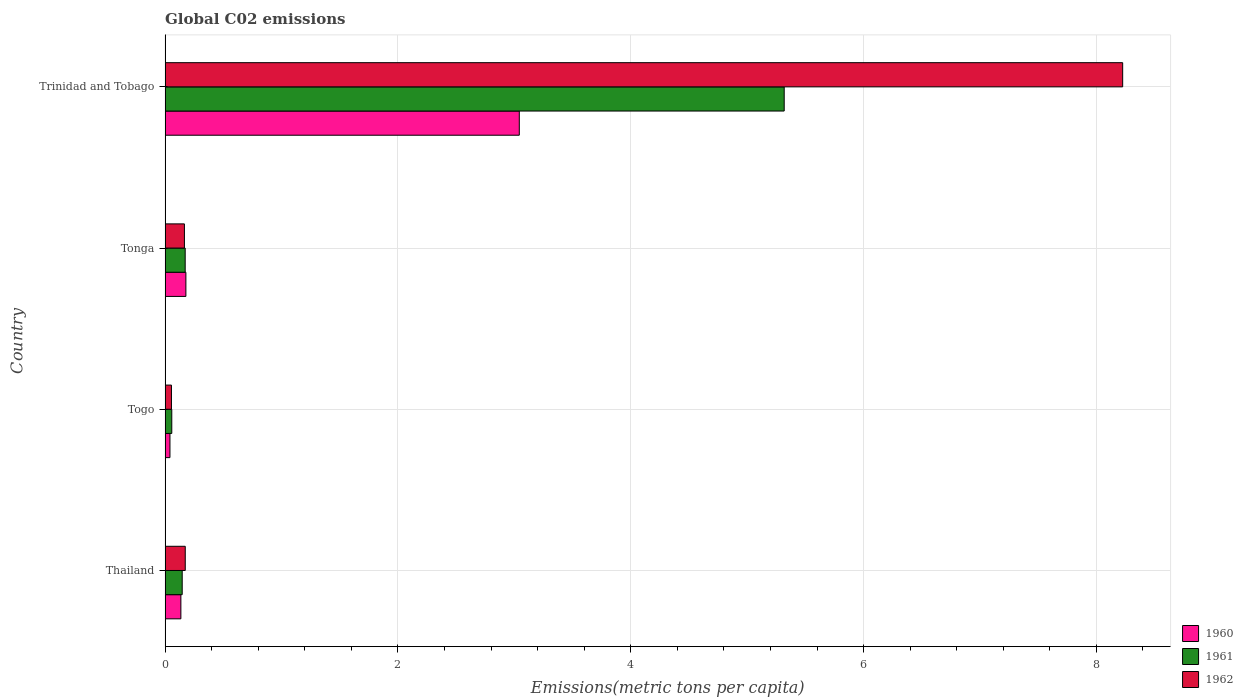How many different coloured bars are there?
Your answer should be compact. 3. How many groups of bars are there?
Keep it short and to the point. 4. How many bars are there on the 1st tick from the top?
Your answer should be compact. 3. What is the label of the 3rd group of bars from the top?
Your response must be concise. Togo. In how many cases, is the number of bars for a given country not equal to the number of legend labels?
Make the answer very short. 0. What is the amount of CO2 emitted in in 1962 in Togo?
Offer a terse response. 0.05. Across all countries, what is the maximum amount of CO2 emitted in in 1961?
Make the answer very short. 5.32. Across all countries, what is the minimum amount of CO2 emitted in in 1962?
Ensure brevity in your answer.  0.05. In which country was the amount of CO2 emitted in in 1962 maximum?
Give a very brief answer. Trinidad and Tobago. In which country was the amount of CO2 emitted in in 1961 minimum?
Offer a terse response. Togo. What is the total amount of CO2 emitted in in 1962 in the graph?
Ensure brevity in your answer.  8.62. What is the difference between the amount of CO2 emitted in in 1961 in Tonga and that in Trinidad and Tobago?
Ensure brevity in your answer.  -5.15. What is the difference between the amount of CO2 emitted in in 1960 in Tonga and the amount of CO2 emitted in in 1961 in Trinidad and Tobago?
Ensure brevity in your answer.  -5.14. What is the average amount of CO2 emitted in in 1961 per country?
Provide a succinct answer. 1.42. What is the difference between the amount of CO2 emitted in in 1962 and amount of CO2 emitted in in 1960 in Tonga?
Give a very brief answer. -0.01. What is the ratio of the amount of CO2 emitted in in 1962 in Thailand to that in Tonga?
Make the answer very short. 1.04. Is the amount of CO2 emitted in in 1961 in Togo less than that in Tonga?
Keep it short and to the point. Yes. Is the difference between the amount of CO2 emitted in in 1962 in Thailand and Tonga greater than the difference between the amount of CO2 emitted in in 1960 in Thailand and Tonga?
Your answer should be compact. Yes. What is the difference between the highest and the second highest amount of CO2 emitted in in 1962?
Make the answer very short. 8.05. What is the difference between the highest and the lowest amount of CO2 emitted in in 1960?
Offer a terse response. 3. In how many countries, is the amount of CO2 emitted in in 1960 greater than the average amount of CO2 emitted in in 1960 taken over all countries?
Provide a short and direct response. 1. Is the sum of the amount of CO2 emitted in in 1962 in Thailand and Tonga greater than the maximum amount of CO2 emitted in in 1960 across all countries?
Your answer should be very brief. No. What does the 3rd bar from the top in Togo represents?
Provide a succinct answer. 1960. What does the 3rd bar from the bottom in Trinidad and Tobago represents?
Your answer should be compact. 1962. Is it the case that in every country, the sum of the amount of CO2 emitted in in 1960 and amount of CO2 emitted in in 1962 is greater than the amount of CO2 emitted in in 1961?
Keep it short and to the point. Yes. How many bars are there?
Your response must be concise. 12. Are all the bars in the graph horizontal?
Provide a short and direct response. Yes. What is the difference between two consecutive major ticks on the X-axis?
Give a very brief answer. 2. Are the values on the major ticks of X-axis written in scientific E-notation?
Offer a terse response. No. Does the graph contain grids?
Keep it short and to the point. Yes. Where does the legend appear in the graph?
Ensure brevity in your answer.  Bottom right. How many legend labels are there?
Ensure brevity in your answer.  3. How are the legend labels stacked?
Provide a short and direct response. Vertical. What is the title of the graph?
Make the answer very short. Global C02 emissions. Does "2005" appear as one of the legend labels in the graph?
Offer a very short reply. No. What is the label or title of the X-axis?
Offer a very short reply. Emissions(metric tons per capita). What is the Emissions(metric tons per capita) of 1960 in Thailand?
Provide a short and direct response. 0.14. What is the Emissions(metric tons per capita) of 1961 in Thailand?
Provide a succinct answer. 0.15. What is the Emissions(metric tons per capita) of 1962 in Thailand?
Give a very brief answer. 0.17. What is the Emissions(metric tons per capita) in 1960 in Togo?
Provide a succinct answer. 0.04. What is the Emissions(metric tons per capita) of 1961 in Togo?
Keep it short and to the point. 0.06. What is the Emissions(metric tons per capita) in 1962 in Togo?
Provide a succinct answer. 0.05. What is the Emissions(metric tons per capita) in 1960 in Tonga?
Provide a succinct answer. 0.18. What is the Emissions(metric tons per capita) in 1961 in Tonga?
Ensure brevity in your answer.  0.17. What is the Emissions(metric tons per capita) in 1962 in Tonga?
Ensure brevity in your answer.  0.17. What is the Emissions(metric tons per capita) in 1960 in Trinidad and Tobago?
Make the answer very short. 3.04. What is the Emissions(metric tons per capita) in 1961 in Trinidad and Tobago?
Provide a short and direct response. 5.32. What is the Emissions(metric tons per capita) of 1962 in Trinidad and Tobago?
Give a very brief answer. 8.23. Across all countries, what is the maximum Emissions(metric tons per capita) of 1960?
Ensure brevity in your answer.  3.04. Across all countries, what is the maximum Emissions(metric tons per capita) of 1961?
Your answer should be compact. 5.32. Across all countries, what is the maximum Emissions(metric tons per capita) in 1962?
Keep it short and to the point. 8.23. Across all countries, what is the minimum Emissions(metric tons per capita) in 1960?
Make the answer very short. 0.04. Across all countries, what is the minimum Emissions(metric tons per capita) in 1961?
Give a very brief answer. 0.06. Across all countries, what is the minimum Emissions(metric tons per capita) of 1962?
Ensure brevity in your answer.  0.05. What is the total Emissions(metric tons per capita) of 1960 in the graph?
Make the answer very short. 3.4. What is the total Emissions(metric tons per capita) in 1961 in the graph?
Your answer should be very brief. 5.7. What is the total Emissions(metric tons per capita) in 1962 in the graph?
Keep it short and to the point. 8.62. What is the difference between the Emissions(metric tons per capita) in 1960 in Thailand and that in Togo?
Make the answer very short. 0.09. What is the difference between the Emissions(metric tons per capita) in 1961 in Thailand and that in Togo?
Offer a very short reply. 0.09. What is the difference between the Emissions(metric tons per capita) of 1962 in Thailand and that in Togo?
Offer a terse response. 0.12. What is the difference between the Emissions(metric tons per capita) of 1960 in Thailand and that in Tonga?
Your answer should be very brief. -0.04. What is the difference between the Emissions(metric tons per capita) in 1961 in Thailand and that in Tonga?
Your answer should be compact. -0.03. What is the difference between the Emissions(metric tons per capita) in 1962 in Thailand and that in Tonga?
Provide a short and direct response. 0.01. What is the difference between the Emissions(metric tons per capita) in 1960 in Thailand and that in Trinidad and Tobago?
Provide a succinct answer. -2.91. What is the difference between the Emissions(metric tons per capita) in 1961 in Thailand and that in Trinidad and Tobago?
Keep it short and to the point. -5.17. What is the difference between the Emissions(metric tons per capita) in 1962 in Thailand and that in Trinidad and Tobago?
Your answer should be compact. -8.05. What is the difference between the Emissions(metric tons per capita) of 1960 in Togo and that in Tonga?
Make the answer very short. -0.14. What is the difference between the Emissions(metric tons per capita) of 1961 in Togo and that in Tonga?
Your answer should be very brief. -0.12. What is the difference between the Emissions(metric tons per capita) of 1962 in Togo and that in Tonga?
Provide a succinct answer. -0.11. What is the difference between the Emissions(metric tons per capita) in 1960 in Togo and that in Trinidad and Tobago?
Keep it short and to the point. -3. What is the difference between the Emissions(metric tons per capita) in 1961 in Togo and that in Trinidad and Tobago?
Your response must be concise. -5.26. What is the difference between the Emissions(metric tons per capita) of 1962 in Togo and that in Trinidad and Tobago?
Provide a short and direct response. -8.17. What is the difference between the Emissions(metric tons per capita) of 1960 in Tonga and that in Trinidad and Tobago?
Keep it short and to the point. -2.86. What is the difference between the Emissions(metric tons per capita) in 1961 in Tonga and that in Trinidad and Tobago?
Offer a very short reply. -5.15. What is the difference between the Emissions(metric tons per capita) in 1962 in Tonga and that in Trinidad and Tobago?
Provide a succinct answer. -8.06. What is the difference between the Emissions(metric tons per capita) in 1960 in Thailand and the Emissions(metric tons per capita) in 1961 in Togo?
Provide a short and direct response. 0.08. What is the difference between the Emissions(metric tons per capita) in 1960 in Thailand and the Emissions(metric tons per capita) in 1962 in Togo?
Offer a very short reply. 0.08. What is the difference between the Emissions(metric tons per capita) in 1961 in Thailand and the Emissions(metric tons per capita) in 1962 in Togo?
Your answer should be very brief. 0.09. What is the difference between the Emissions(metric tons per capita) in 1960 in Thailand and the Emissions(metric tons per capita) in 1961 in Tonga?
Make the answer very short. -0.04. What is the difference between the Emissions(metric tons per capita) of 1960 in Thailand and the Emissions(metric tons per capita) of 1962 in Tonga?
Provide a short and direct response. -0.03. What is the difference between the Emissions(metric tons per capita) of 1961 in Thailand and the Emissions(metric tons per capita) of 1962 in Tonga?
Keep it short and to the point. -0.02. What is the difference between the Emissions(metric tons per capita) of 1960 in Thailand and the Emissions(metric tons per capita) of 1961 in Trinidad and Tobago?
Your response must be concise. -5.18. What is the difference between the Emissions(metric tons per capita) of 1960 in Thailand and the Emissions(metric tons per capita) of 1962 in Trinidad and Tobago?
Your answer should be compact. -8.09. What is the difference between the Emissions(metric tons per capita) of 1961 in Thailand and the Emissions(metric tons per capita) of 1962 in Trinidad and Tobago?
Provide a short and direct response. -8.08. What is the difference between the Emissions(metric tons per capita) in 1960 in Togo and the Emissions(metric tons per capita) in 1961 in Tonga?
Offer a terse response. -0.13. What is the difference between the Emissions(metric tons per capita) in 1960 in Togo and the Emissions(metric tons per capita) in 1962 in Tonga?
Provide a short and direct response. -0.12. What is the difference between the Emissions(metric tons per capita) of 1961 in Togo and the Emissions(metric tons per capita) of 1962 in Tonga?
Ensure brevity in your answer.  -0.11. What is the difference between the Emissions(metric tons per capita) in 1960 in Togo and the Emissions(metric tons per capita) in 1961 in Trinidad and Tobago?
Your answer should be compact. -5.28. What is the difference between the Emissions(metric tons per capita) in 1960 in Togo and the Emissions(metric tons per capita) in 1962 in Trinidad and Tobago?
Offer a very short reply. -8.18. What is the difference between the Emissions(metric tons per capita) of 1961 in Togo and the Emissions(metric tons per capita) of 1962 in Trinidad and Tobago?
Give a very brief answer. -8.17. What is the difference between the Emissions(metric tons per capita) in 1960 in Tonga and the Emissions(metric tons per capita) in 1961 in Trinidad and Tobago?
Offer a terse response. -5.14. What is the difference between the Emissions(metric tons per capita) of 1960 in Tonga and the Emissions(metric tons per capita) of 1962 in Trinidad and Tobago?
Give a very brief answer. -8.05. What is the difference between the Emissions(metric tons per capita) in 1961 in Tonga and the Emissions(metric tons per capita) in 1962 in Trinidad and Tobago?
Provide a succinct answer. -8.05. What is the average Emissions(metric tons per capita) in 1960 per country?
Your answer should be very brief. 0.85. What is the average Emissions(metric tons per capita) in 1961 per country?
Offer a very short reply. 1.42. What is the average Emissions(metric tons per capita) in 1962 per country?
Make the answer very short. 2.15. What is the difference between the Emissions(metric tons per capita) in 1960 and Emissions(metric tons per capita) in 1961 in Thailand?
Your answer should be very brief. -0.01. What is the difference between the Emissions(metric tons per capita) in 1960 and Emissions(metric tons per capita) in 1962 in Thailand?
Provide a short and direct response. -0.04. What is the difference between the Emissions(metric tons per capita) in 1961 and Emissions(metric tons per capita) in 1962 in Thailand?
Offer a terse response. -0.03. What is the difference between the Emissions(metric tons per capita) of 1960 and Emissions(metric tons per capita) of 1961 in Togo?
Your answer should be very brief. -0.02. What is the difference between the Emissions(metric tons per capita) in 1960 and Emissions(metric tons per capita) in 1962 in Togo?
Keep it short and to the point. -0.01. What is the difference between the Emissions(metric tons per capita) of 1961 and Emissions(metric tons per capita) of 1962 in Togo?
Give a very brief answer. 0. What is the difference between the Emissions(metric tons per capita) in 1960 and Emissions(metric tons per capita) in 1961 in Tonga?
Give a very brief answer. 0.01. What is the difference between the Emissions(metric tons per capita) of 1960 and Emissions(metric tons per capita) of 1962 in Tonga?
Offer a terse response. 0.01. What is the difference between the Emissions(metric tons per capita) of 1961 and Emissions(metric tons per capita) of 1962 in Tonga?
Your response must be concise. 0.01. What is the difference between the Emissions(metric tons per capita) of 1960 and Emissions(metric tons per capita) of 1961 in Trinidad and Tobago?
Provide a succinct answer. -2.28. What is the difference between the Emissions(metric tons per capita) of 1960 and Emissions(metric tons per capita) of 1962 in Trinidad and Tobago?
Ensure brevity in your answer.  -5.18. What is the difference between the Emissions(metric tons per capita) of 1961 and Emissions(metric tons per capita) of 1962 in Trinidad and Tobago?
Provide a short and direct response. -2.91. What is the ratio of the Emissions(metric tons per capita) in 1960 in Thailand to that in Togo?
Your answer should be very brief. 3.25. What is the ratio of the Emissions(metric tons per capita) of 1961 in Thailand to that in Togo?
Make the answer very short. 2.56. What is the ratio of the Emissions(metric tons per capita) of 1962 in Thailand to that in Togo?
Offer a very short reply. 3.17. What is the ratio of the Emissions(metric tons per capita) in 1960 in Thailand to that in Tonga?
Your answer should be very brief. 0.76. What is the ratio of the Emissions(metric tons per capita) of 1961 in Thailand to that in Tonga?
Ensure brevity in your answer.  0.85. What is the ratio of the Emissions(metric tons per capita) in 1962 in Thailand to that in Tonga?
Your answer should be compact. 1.04. What is the ratio of the Emissions(metric tons per capita) in 1960 in Thailand to that in Trinidad and Tobago?
Offer a very short reply. 0.04. What is the ratio of the Emissions(metric tons per capita) in 1961 in Thailand to that in Trinidad and Tobago?
Give a very brief answer. 0.03. What is the ratio of the Emissions(metric tons per capita) in 1962 in Thailand to that in Trinidad and Tobago?
Your response must be concise. 0.02. What is the ratio of the Emissions(metric tons per capita) of 1960 in Togo to that in Tonga?
Ensure brevity in your answer.  0.23. What is the ratio of the Emissions(metric tons per capita) in 1961 in Togo to that in Tonga?
Your answer should be very brief. 0.33. What is the ratio of the Emissions(metric tons per capita) in 1962 in Togo to that in Tonga?
Provide a succinct answer. 0.33. What is the ratio of the Emissions(metric tons per capita) in 1960 in Togo to that in Trinidad and Tobago?
Your response must be concise. 0.01. What is the ratio of the Emissions(metric tons per capita) in 1961 in Togo to that in Trinidad and Tobago?
Make the answer very short. 0.01. What is the ratio of the Emissions(metric tons per capita) in 1962 in Togo to that in Trinidad and Tobago?
Offer a very short reply. 0.01. What is the ratio of the Emissions(metric tons per capita) of 1960 in Tonga to that in Trinidad and Tobago?
Keep it short and to the point. 0.06. What is the ratio of the Emissions(metric tons per capita) of 1961 in Tonga to that in Trinidad and Tobago?
Provide a short and direct response. 0.03. What is the ratio of the Emissions(metric tons per capita) of 1962 in Tonga to that in Trinidad and Tobago?
Give a very brief answer. 0.02. What is the difference between the highest and the second highest Emissions(metric tons per capita) of 1960?
Your response must be concise. 2.86. What is the difference between the highest and the second highest Emissions(metric tons per capita) of 1961?
Your answer should be compact. 5.15. What is the difference between the highest and the second highest Emissions(metric tons per capita) of 1962?
Your answer should be compact. 8.05. What is the difference between the highest and the lowest Emissions(metric tons per capita) in 1960?
Give a very brief answer. 3. What is the difference between the highest and the lowest Emissions(metric tons per capita) of 1961?
Ensure brevity in your answer.  5.26. What is the difference between the highest and the lowest Emissions(metric tons per capita) in 1962?
Ensure brevity in your answer.  8.17. 